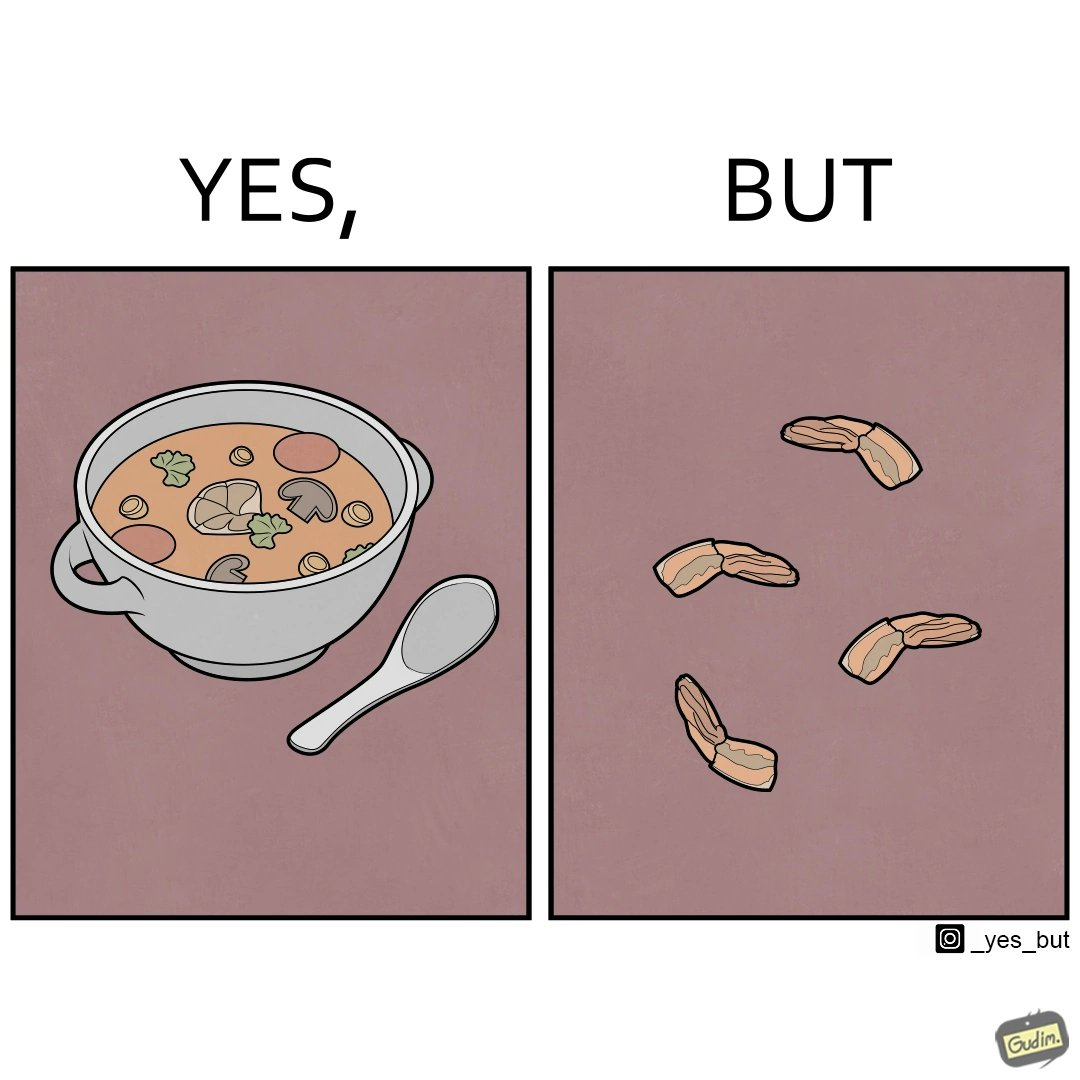Compare the left and right sides of this image. In the left part of the image: There is a cup of soup. In the right part of the image: Vegetables that are left. 